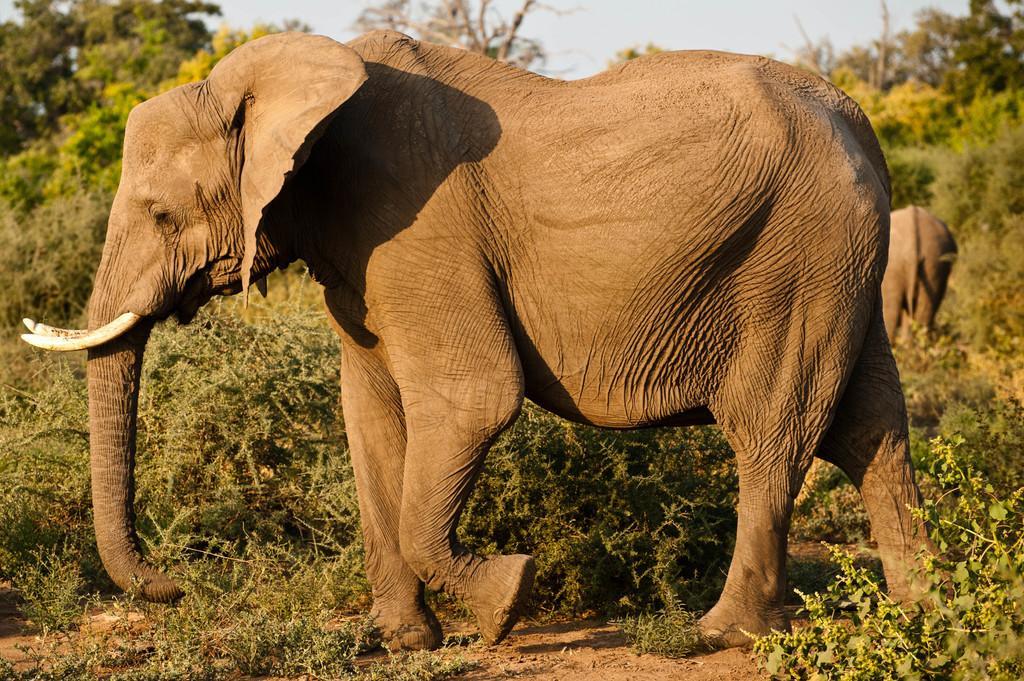Can you describe this image briefly? In this image there are elephants. In the background there are trees and sky. 